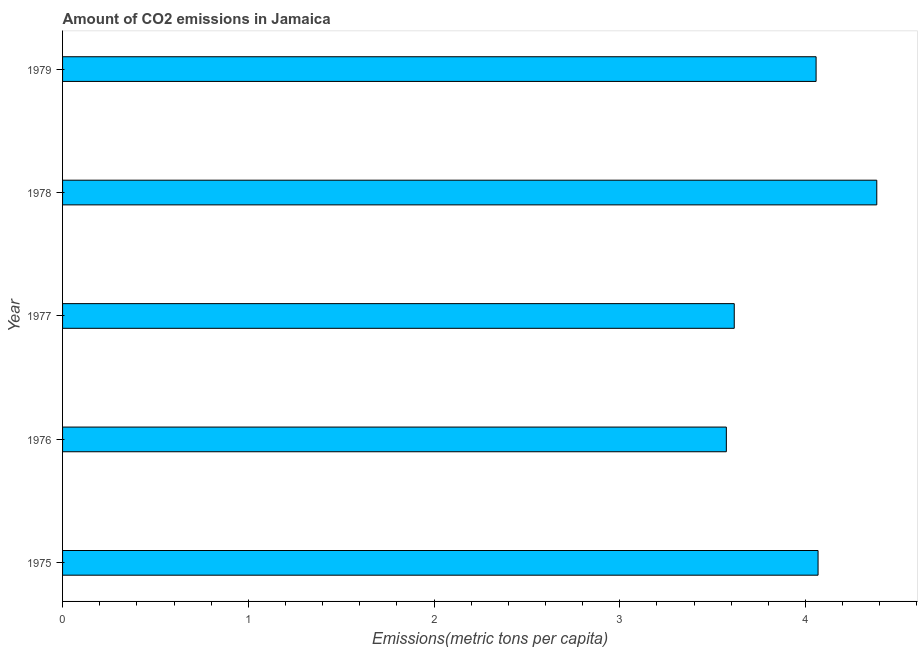Does the graph contain any zero values?
Offer a very short reply. No. What is the title of the graph?
Provide a short and direct response. Amount of CO2 emissions in Jamaica. What is the label or title of the X-axis?
Provide a succinct answer. Emissions(metric tons per capita). What is the label or title of the Y-axis?
Offer a terse response. Year. What is the amount of co2 emissions in 1978?
Ensure brevity in your answer.  4.38. Across all years, what is the maximum amount of co2 emissions?
Make the answer very short. 4.38. Across all years, what is the minimum amount of co2 emissions?
Your answer should be very brief. 3.57. In which year was the amount of co2 emissions maximum?
Your response must be concise. 1978. In which year was the amount of co2 emissions minimum?
Give a very brief answer. 1976. What is the sum of the amount of co2 emissions?
Ensure brevity in your answer.  19.7. What is the difference between the amount of co2 emissions in 1978 and 1979?
Offer a very short reply. 0.33. What is the average amount of co2 emissions per year?
Make the answer very short. 3.94. What is the median amount of co2 emissions?
Your answer should be compact. 4.06. Do a majority of the years between 1979 and 1978 (inclusive) have amount of co2 emissions greater than 0.8 metric tons per capita?
Your response must be concise. No. What is the ratio of the amount of co2 emissions in 1975 to that in 1976?
Give a very brief answer. 1.14. Is the amount of co2 emissions in 1977 less than that in 1979?
Your answer should be compact. Yes. Is the difference between the amount of co2 emissions in 1977 and 1978 greater than the difference between any two years?
Your answer should be very brief. No. What is the difference between the highest and the second highest amount of co2 emissions?
Give a very brief answer. 0.32. Is the sum of the amount of co2 emissions in 1978 and 1979 greater than the maximum amount of co2 emissions across all years?
Make the answer very short. Yes. What is the difference between the highest and the lowest amount of co2 emissions?
Keep it short and to the point. 0.81. How many years are there in the graph?
Make the answer very short. 5. What is the difference between two consecutive major ticks on the X-axis?
Offer a terse response. 1. What is the Emissions(metric tons per capita) of 1975?
Offer a very short reply. 4.07. What is the Emissions(metric tons per capita) in 1976?
Offer a terse response. 3.57. What is the Emissions(metric tons per capita) in 1977?
Ensure brevity in your answer.  3.62. What is the Emissions(metric tons per capita) in 1978?
Offer a very short reply. 4.38. What is the Emissions(metric tons per capita) in 1979?
Give a very brief answer. 4.06. What is the difference between the Emissions(metric tons per capita) in 1975 and 1976?
Offer a terse response. 0.49. What is the difference between the Emissions(metric tons per capita) in 1975 and 1977?
Your response must be concise. 0.45. What is the difference between the Emissions(metric tons per capita) in 1975 and 1978?
Keep it short and to the point. -0.32. What is the difference between the Emissions(metric tons per capita) in 1975 and 1979?
Your answer should be compact. 0.01. What is the difference between the Emissions(metric tons per capita) in 1976 and 1977?
Offer a very short reply. -0.04. What is the difference between the Emissions(metric tons per capita) in 1976 and 1978?
Your response must be concise. -0.81. What is the difference between the Emissions(metric tons per capita) in 1976 and 1979?
Make the answer very short. -0.48. What is the difference between the Emissions(metric tons per capita) in 1977 and 1978?
Your answer should be compact. -0.77. What is the difference between the Emissions(metric tons per capita) in 1977 and 1979?
Make the answer very short. -0.44. What is the difference between the Emissions(metric tons per capita) in 1978 and 1979?
Offer a terse response. 0.33. What is the ratio of the Emissions(metric tons per capita) in 1975 to that in 1976?
Your response must be concise. 1.14. What is the ratio of the Emissions(metric tons per capita) in 1975 to that in 1977?
Make the answer very short. 1.12. What is the ratio of the Emissions(metric tons per capita) in 1975 to that in 1978?
Your answer should be compact. 0.93. What is the ratio of the Emissions(metric tons per capita) in 1975 to that in 1979?
Your response must be concise. 1. What is the ratio of the Emissions(metric tons per capita) in 1976 to that in 1978?
Offer a terse response. 0.81. What is the ratio of the Emissions(metric tons per capita) in 1976 to that in 1979?
Offer a terse response. 0.88. What is the ratio of the Emissions(metric tons per capita) in 1977 to that in 1978?
Offer a very short reply. 0.82. What is the ratio of the Emissions(metric tons per capita) in 1977 to that in 1979?
Give a very brief answer. 0.89. What is the ratio of the Emissions(metric tons per capita) in 1978 to that in 1979?
Give a very brief answer. 1.08. 